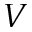Convert formula to latex. <formula><loc_0><loc_0><loc_500><loc_500>V</formula> 